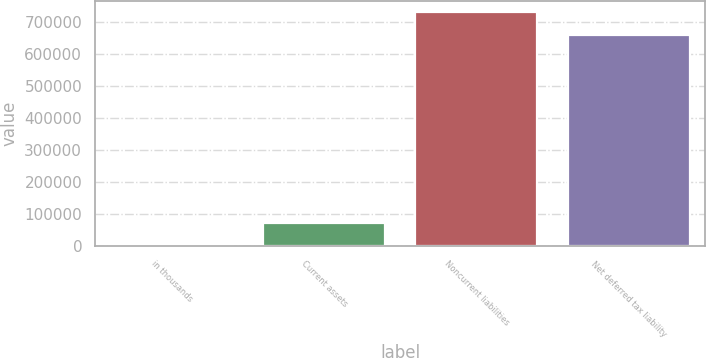<chart> <loc_0><loc_0><loc_500><loc_500><bar_chart><fcel>in thousands<fcel>Current assets<fcel>Noncurrent liabilities<fcel>Net deferred tax liability<nl><fcel>2013<fcel>71919.2<fcel>730558<fcel>660652<nl></chart> 